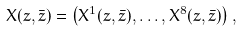<formula> <loc_0><loc_0><loc_500><loc_500>X ( z , \bar { z } ) = \left ( X ^ { 1 } ( z , \bar { z } ) , \dots , X ^ { 8 } ( z , \bar { z } ) \right ) ,</formula> 